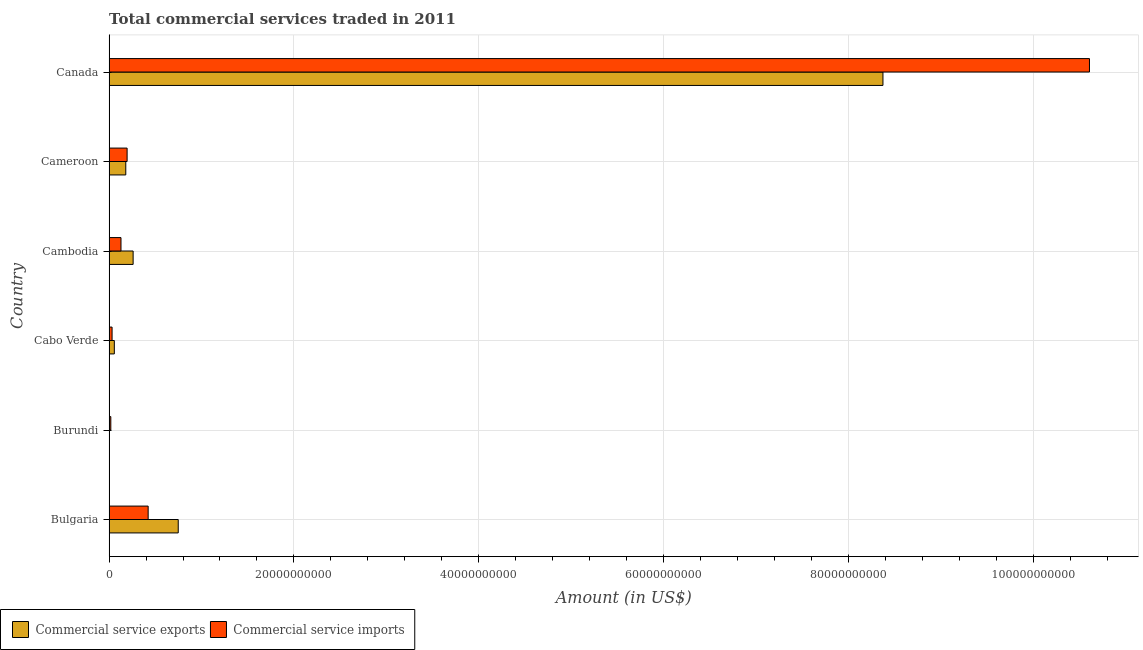How many groups of bars are there?
Your answer should be very brief. 6. Are the number of bars on each tick of the Y-axis equal?
Give a very brief answer. Yes. What is the label of the 2nd group of bars from the top?
Ensure brevity in your answer.  Cameroon. In how many cases, is the number of bars for a given country not equal to the number of legend labels?
Your response must be concise. 0. What is the amount of commercial service imports in Canada?
Ensure brevity in your answer.  1.06e+11. Across all countries, what is the maximum amount of commercial service exports?
Your answer should be very brief. 8.37e+1. Across all countries, what is the minimum amount of commercial service imports?
Provide a short and direct response. 1.89e+08. In which country was the amount of commercial service exports minimum?
Keep it short and to the point. Burundi. What is the total amount of commercial service exports in the graph?
Ensure brevity in your answer.  9.62e+1. What is the difference between the amount of commercial service exports in Bulgaria and that in Cabo Verde?
Keep it short and to the point. 6.91e+09. What is the difference between the amount of commercial service imports in Canada and the amount of commercial service exports in Cabo Verde?
Provide a succinct answer. 1.05e+11. What is the average amount of commercial service exports per country?
Your answer should be compact. 1.60e+1. What is the difference between the amount of commercial service imports and amount of commercial service exports in Burundi?
Keep it short and to the point. 1.70e+08. What is the ratio of the amount of commercial service imports in Cabo Verde to that in Cambodia?
Your response must be concise. 0.25. What is the difference between the highest and the second highest amount of commercial service exports?
Make the answer very short. 7.62e+1. What is the difference between the highest and the lowest amount of commercial service exports?
Your response must be concise. 8.37e+1. In how many countries, is the amount of commercial service imports greater than the average amount of commercial service imports taken over all countries?
Ensure brevity in your answer.  1. Is the sum of the amount of commercial service exports in Burundi and Canada greater than the maximum amount of commercial service imports across all countries?
Give a very brief answer. No. What does the 2nd bar from the top in Cameroon represents?
Make the answer very short. Commercial service exports. What does the 1st bar from the bottom in Cameroon represents?
Your response must be concise. Commercial service exports. How many bars are there?
Your answer should be very brief. 12. Does the graph contain any zero values?
Provide a short and direct response. No. Does the graph contain grids?
Your answer should be compact. Yes. How are the legend labels stacked?
Your response must be concise. Horizontal. What is the title of the graph?
Ensure brevity in your answer.  Total commercial services traded in 2011. What is the Amount (in US$) in Commercial service exports in Bulgaria?
Give a very brief answer. 7.48e+09. What is the Amount (in US$) of Commercial service imports in Bulgaria?
Provide a short and direct response. 4.23e+09. What is the Amount (in US$) of Commercial service exports in Burundi?
Your answer should be very brief. 1.96e+07. What is the Amount (in US$) of Commercial service imports in Burundi?
Offer a very short reply. 1.89e+08. What is the Amount (in US$) in Commercial service exports in Cabo Verde?
Provide a succinct answer. 5.69e+08. What is the Amount (in US$) of Commercial service imports in Cabo Verde?
Provide a short and direct response. 3.26e+08. What is the Amount (in US$) in Commercial service exports in Cambodia?
Your answer should be compact. 2.60e+09. What is the Amount (in US$) of Commercial service imports in Cambodia?
Your answer should be very brief. 1.29e+09. What is the Amount (in US$) of Commercial service exports in Cameroon?
Your answer should be very brief. 1.81e+09. What is the Amount (in US$) of Commercial service imports in Cameroon?
Provide a succinct answer. 1.95e+09. What is the Amount (in US$) in Commercial service exports in Canada?
Keep it short and to the point. 8.37e+1. What is the Amount (in US$) of Commercial service imports in Canada?
Make the answer very short. 1.06e+11. Across all countries, what is the maximum Amount (in US$) of Commercial service exports?
Your answer should be compact. 8.37e+1. Across all countries, what is the maximum Amount (in US$) in Commercial service imports?
Offer a very short reply. 1.06e+11. Across all countries, what is the minimum Amount (in US$) of Commercial service exports?
Provide a short and direct response. 1.96e+07. Across all countries, what is the minimum Amount (in US$) of Commercial service imports?
Give a very brief answer. 1.89e+08. What is the total Amount (in US$) of Commercial service exports in the graph?
Keep it short and to the point. 9.62e+1. What is the total Amount (in US$) of Commercial service imports in the graph?
Your answer should be very brief. 1.14e+11. What is the difference between the Amount (in US$) in Commercial service exports in Bulgaria and that in Burundi?
Provide a short and direct response. 7.46e+09. What is the difference between the Amount (in US$) in Commercial service imports in Bulgaria and that in Burundi?
Provide a succinct answer. 4.04e+09. What is the difference between the Amount (in US$) of Commercial service exports in Bulgaria and that in Cabo Verde?
Your response must be concise. 6.91e+09. What is the difference between the Amount (in US$) of Commercial service imports in Bulgaria and that in Cabo Verde?
Give a very brief answer. 3.90e+09. What is the difference between the Amount (in US$) of Commercial service exports in Bulgaria and that in Cambodia?
Your response must be concise. 4.88e+09. What is the difference between the Amount (in US$) in Commercial service imports in Bulgaria and that in Cambodia?
Provide a short and direct response. 2.94e+09. What is the difference between the Amount (in US$) of Commercial service exports in Bulgaria and that in Cameroon?
Your answer should be very brief. 5.67e+09. What is the difference between the Amount (in US$) in Commercial service imports in Bulgaria and that in Cameroon?
Your answer should be very brief. 2.28e+09. What is the difference between the Amount (in US$) of Commercial service exports in Bulgaria and that in Canada?
Offer a very short reply. -7.62e+1. What is the difference between the Amount (in US$) of Commercial service imports in Bulgaria and that in Canada?
Your answer should be very brief. -1.02e+11. What is the difference between the Amount (in US$) of Commercial service exports in Burundi and that in Cabo Verde?
Offer a very short reply. -5.49e+08. What is the difference between the Amount (in US$) of Commercial service imports in Burundi and that in Cabo Verde?
Your response must be concise. -1.36e+08. What is the difference between the Amount (in US$) of Commercial service exports in Burundi and that in Cambodia?
Your answer should be compact. -2.58e+09. What is the difference between the Amount (in US$) in Commercial service imports in Burundi and that in Cambodia?
Make the answer very short. -1.10e+09. What is the difference between the Amount (in US$) of Commercial service exports in Burundi and that in Cameroon?
Offer a terse response. -1.79e+09. What is the difference between the Amount (in US$) of Commercial service imports in Burundi and that in Cameroon?
Your answer should be compact. -1.76e+09. What is the difference between the Amount (in US$) in Commercial service exports in Burundi and that in Canada?
Your answer should be compact. -8.37e+1. What is the difference between the Amount (in US$) of Commercial service imports in Burundi and that in Canada?
Provide a short and direct response. -1.06e+11. What is the difference between the Amount (in US$) in Commercial service exports in Cabo Verde and that in Cambodia?
Your answer should be very brief. -2.03e+09. What is the difference between the Amount (in US$) in Commercial service imports in Cabo Verde and that in Cambodia?
Your answer should be very brief. -9.63e+08. What is the difference between the Amount (in US$) in Commercial service exports in Cabo Verde and that in Cameroon?
Offer a terse response. -1.24e+09. What is the difference between the Amount (in US$) of Commercial service imports in Cabo Verde and that in Cameroon?
Ensure brevity in your answer.  -1.63e+09. What is the difference between the Amount (in US$) of Commercial service exports in Cabo Verde and that in Canada?
Provide a short and direct response. -8.32e+1. What is the difference between the Amount (in US$) of Commercial service imports in Cabo Verde and that in Canada?
Provide a short and direct response. -1.06e+11. What is the difference between the Amount (in US$) in Commercial service exports in Cambodia and that in Cameroon?
Give a very brief answer. 7.94e+08. What is the difference between the Amount (in US$) in Commercial service imports in Cambodia and that in Cameroon?
Make the answer very short. -6.62e+08. What is the difference between the Amount (in US$) in Commercial service exports in Cambodia and that in Canada?
Offer a very short reply. -8.11e+1. What is the difference between the Amount (in US$) of Commercial service imports in Cambodia and that in Canada?
Give a very brief answer. -1.05e+11. What is the difference between the Amount (in US$) in Commercial service exports in Cameroon and that in Canada?
Keep it short and to the point. -8.19e+1. What is the difference between the Amount (in US$) in Commercial service imports in Cameroon and that in Canada?
Offer a terse response. -1.04e+11. What is the difference between the Amount (in US$) in Commercial service exports in Bulgaria and the Amount (in US$) in Commercial service imports in Burundi?
Offer a terse response. 7.29e+09. What is the difference between the Amount (in US$) in Commercial service exports in Bulgaria and the Amount (in US$) in Commercial service imports in Cabo Verde?
Offer a very short reply. 7.16e+09. What is the difference between the Amount (in US$) in Commercial service exports in Bulgaria and the Amount (in US$) in Commercial service imports in Cambodia?
Your answer should be very brief. 6.19e+09. What is the difference between the Amount (in US$) of Commercial service exports in Bulgaria and the Amount (in US$) of Commercial service imports in Cameroon?
Give a very brief answer. 5.53e+09. What is the difference between the Amount (in US$) in Commercial service exports in Bulgaria and the Amount (in US$) in Commercial service imports in Canada?
Ensure brevity in your answer.  -9.86e+1. What is the difference between the Amount (in US$) in Commercial service exports in Burundi and the Amount (in US$) in Commercial service imports in Cabo Verde?
Ensure brevity in your answer.  -3.06e+08. What is the difference between the Amount (in US$) in Commercial service exports in Burundi and the Amount (in US$) in Commercial service imports in Cambodia?
Offer a terse response. -1.27e+09. What is the difference between the Amount (in US$) in Commercial service exports in Burundi and the Amount (in US$) in Commercial service imports in Cameroon?
Your answer should be very brief. -1.93e+09. What is the difference between the Amount (in US$) in Commercial service exports in Burundi and the Amount (in US$) in Commercial service imports in Canada?
Offer a very short reply. -1.06e+11. What is the difference between the Amount (in US$) of Commercial service exports in Cabo Verde and the Amount (in US$) of Commercial service imports in Cambodia?
Provide a short and direct response. -7.20e+08. What is the difference between the Amount (in US$) of Commercial service exports in Cabo Verde and the Amount (in US$) of Commercial service imports in Cameroon?
Make the answer very short. -1.38e+09. What is the difference between the Amount (in US$) of Commercial service exports in Cabo Verde and the Amount (in US$) of Commercial service imports in Canada?
Your answer should be compact. -1.05e+11. What is the difference between the Amount (in US$) of Commercial service exports in Cambodia and the Amount (in US$) of Commercial service imports in Cameroon?
Your response must be concise. 6.51e+08. What is the difference between the Amount (in US$) of Commercial service exports in Cambodia and the Amount (in US$) of Commercial service imports in Canada?
Give a very brief answer. -1.03e+11. What is the difference between the Amount (in US$) of Commercial service exports in Cameroon and the Amount (in US$) of Commercial service imports in Canada?
Ensure brevity in your answer.  -1.04e+11. What is the average Amount (in US$) of Commercial service exports per country?
Offer a terse response. 1.60e+1. What is the average Amount (in US$) of Commercial service imports per country?
Your answer should be very brief. 1.90e+1. What is the difference between the Amount (in US$) in Commercial service exports and Amount (in US$) in Commercial service imports in Bulgaria?
Your answer should be very brief. 3.25e+09. What is the difference between the Amount (in US$) of Commercial service exports and Amount (in US$) of Commercial service imports in Burundi?
Provide a succinct answer. -1.70e+08. What is the difference between the Amount (in US$) in Commercial service exports and Amount (in US$) in Commercial service imports in Cabo Verde?
Your answer should be very brief. 2.43e+08. What is the difference between the Amount (in US$) in Commercial service exports and Amount (in US$) in Commercial service imports in Cambodia?
Ensure brevity in your answer.  1.31e+09. What is the difference between the Amount (in US$) of Commercial service exports and Amount (in US$) of Commercial service imports in Cameroon?
Your answer should be compact. -1.43e+08. What is the difference between the Amount (in US$) in Commercial service exports and Amount (in US$) in Commercial service imports in Canada?
Your answer should be compact. -2.23e+1. What is the ratio of the Amount (in US$) of Commercial service exports in Bulgaria to that in Burundi?
Keep it short and to the point. 382.05. What is the ratio of the Amount (in US$) in Commercial service imports in Bulgaria to that in Burundi?
Keep it short and to the point. 22.32. What is the ratio of the Amount (in US$) in Commercial service exports in Bulgaria to that in Cabo Verde?
Provide a succinct answer. 13.15. What is the ratio of the Amount (in US$) in Commercial service imports in Bulgaria to that in Cabo Verde?
Give a very brief answer. 12.99. What is the ratio of the Amount (in US$) in Commercial service exports in Bulgaria to that in Cambodia?
Keep it short and to the point. 2.88. What is the ratio of the Amount (in US$) of Commercial service imports in Bulgaria to that in Cambodia?
Give a very brief answer. 3.28. What is the ratio of the Amount (in US$) in Commercial service exports in Bulgaria to that in Cameroon?
Provide a succinct answer. 4.14. What is the ratio of the Amount (in US$) in Commercial service imports in Bulgaria to that in Cameroon?
Your answer should be very brief. 2.17. What is the ratio of the Amount (in US$) in Commercial service exports in Bulgaria to that in Canada?
Keep it short and to the point. 0.09. What is the ratio of the Amount (in US$) of Commercial service imports in Bulgaria to that in Canada?
Your response must be concise. 0.04. What is the ratio of the Amount (in US$) in Commercial service exports in Burundi to that in Cabo Verde?
Offer a terse response. 0.03. What is the ratio of the Amount (in US$) in Commercial service imports in Burundi to that in Cabo Verde?
Offer a terse response. 0.58. What is the ratio of the Amount (in US$) of Commercial service exports in Burundi to that in Cambodia?
Give a very brief answer. 0.01. What is the ratio of the Amount (in US$) of Commercial service imports in Burundi to that in Cambodia?
Your response must be concise. 0.15. What is the ratio of the Amount (in US$) of Commercial service exports in Burundi to that in Cameroon?
Make the answer very short. 0.01. What is the ratio of the Amount (in US$) of Commercial service imports in Burundi to that in Cameroon?
Offer a terse response. 0.1. What is the ratio of the Amount (in US$) of Commercial service imports in Burundi to that in Canada?
Ensure brevity in your answer.  0. What is the ratio of the Amount (in US$) of Commercial service exports in Cabo Verde to that in Cambodia?
Provide a succinct answer. 0.22. What is the ratio of the Amount (in US$) in Commercial service imports in Cabo Verde to that in Cambodia?
Make the answer very short. 0.25. What is the ratio of the Amount (in US$) in Commercial service exports in Cabo Verde to that in Cameroon?
Make the answer very short. 0.31. What is the ratio of the Amount (in US$) in Commercial service imports in Cabo Verde to that in Cameroon?
Offer a very short reply. 0.17. What is the ratio of the Amount (in US$) in Commercial service exports in Cabo Verde to that in Canada?
Offer a terse response. 0.01. What is the ratio of the Amount (in US$) in Commercial service imports in Cabo Verde to that in Canada?
Make the answer very short. 0. What is the ratio of the Amount (in US$) in Commercial service exports in Cambodia to that in Cameroon?
Provide a succinct answer. 1.44. What is the ratio of the Amount (in US$) of Commercial service imports in Cambodia to that in Cameroon?
Make the answer very short. 0.66. What is the ratio of the Amount (in US$) of Commercial service exports in Cambodia to that in Canada?
Provide a succinct answer. 0.03. What is the ratio of the Amount (in US$) of Commercial service imports in Cambodia to that in Canada?
Ensure brevity in your answer.  0.01. What is the ratio of the Amount (in US$) of Commercial service exports in Cameroon to that in Canada?
Provide a short and direct response. 0.02. What is the ratio of the Amount (in US$) in Commercial service imports in Cameroon to that in Canada?
Ensure brevity in your answer.  0.02. What is the difference between the highest and the second highest Amount (in US$) of Commercial service exports?
Your answer should be very brief. 7.62e+1. What is the difference between the highest and the second highest Amount (in US$) in Commercial service imports?
Your response must be concise. 1.02e+11. What is the difference between the highest and the lowest Amount (in US$) of Commercial service exports?
Your response must be concise. 8.37e+1. What is the difference between the highest and the lowest Amount (in US$) in Commercial service imports?
Keep it short and to the point. 1.06e+11. 